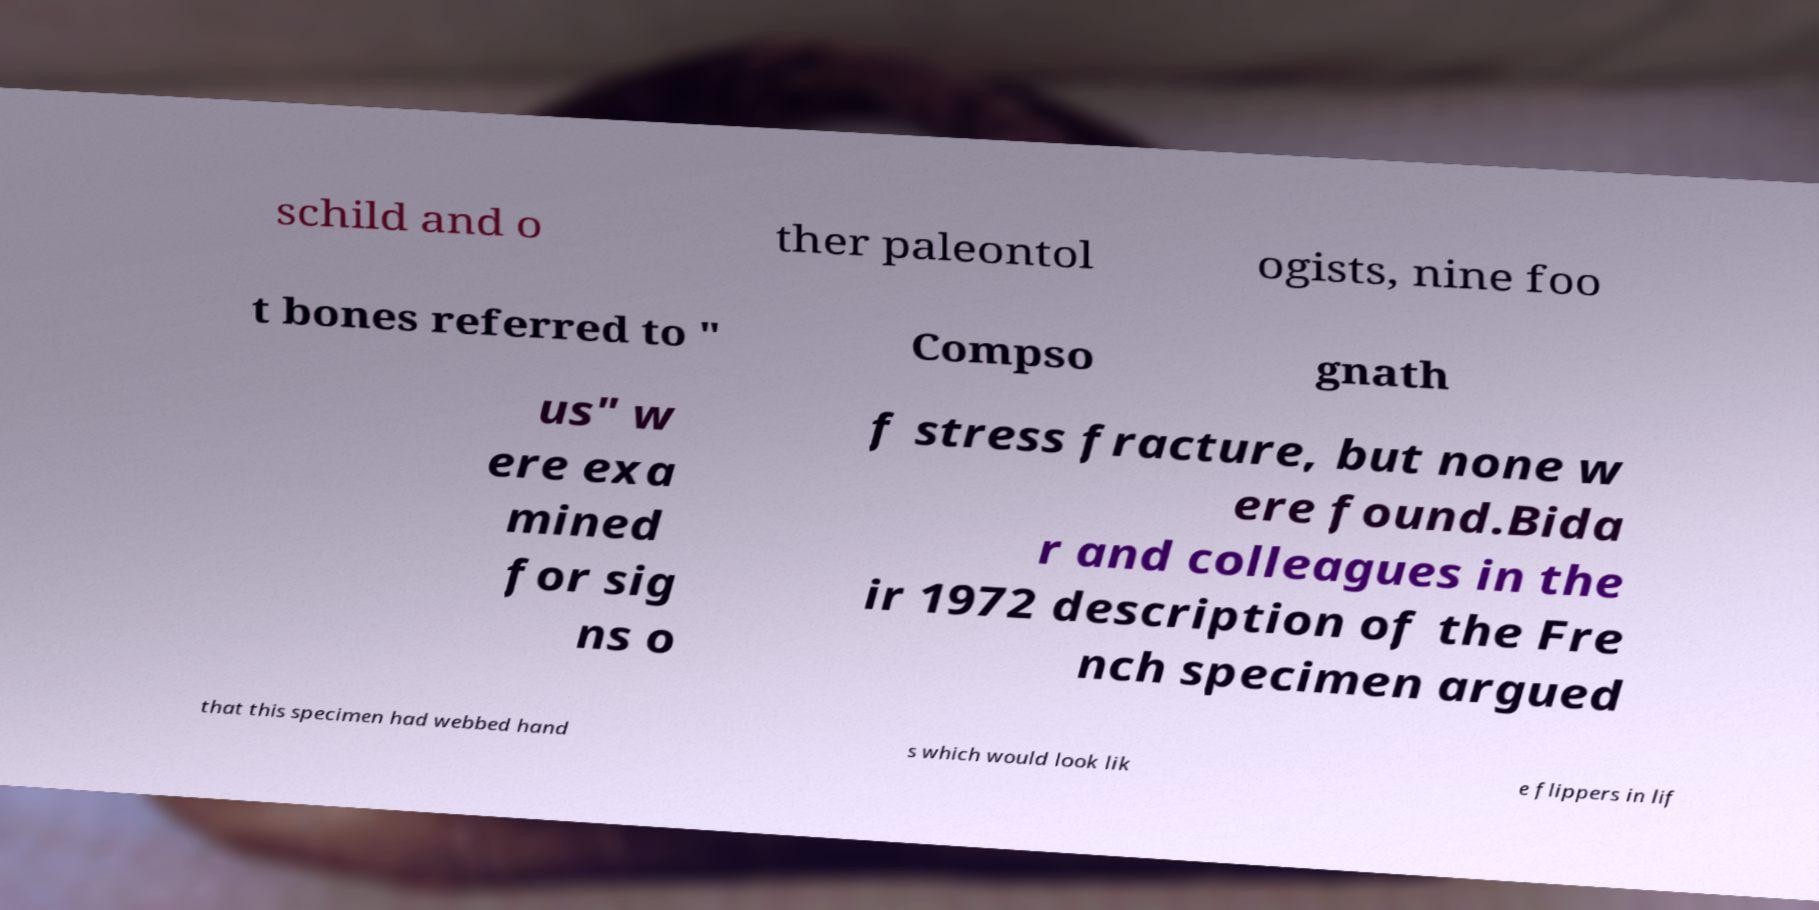Please read and relay the text visible in this image. What does it say? schild and o ther paleontol ogists, nine foo t bones referred to " Compso gnath us" w ere exa mined for sig ns o f stress fracture, but none w ere found.Bida r and colleagues in the ir 1972 description of the Fre nch specimen argued that this specimen had webbed hand s which would look lik e flippers in lif 